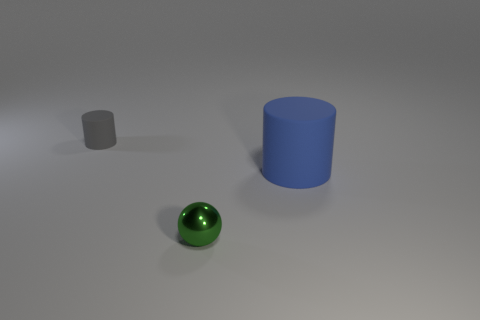Is the number of shiny cylinders greater than the number of large rubber cylinders?
Your answer should be very brief. No. Are there any other things that are the same color as the small matte thing?
Provide a succinct answer. No. The cylinder that is in front of the tiny thing behind the big blue matte cylinder is made of what material?
Your response must be concise. Rubber. There is a object on the left side of the small green object; is its shape the same as the small green object?
Offer a terse response. No. Is the number of rubber cylinders on the right side of the blue thing greater than the number of blue cylinders?
Your answer should be very brief. No. Is there any other thing that has the same material as the green object?
Provide a short and direct response. No. How many blocks are either small things or big blue things?
Offer a very short reply. 0. There is a rubber object to the left of the large blue cylinder on the right side of the tiny matte cylinder; what is its color?
Offer a very short reply. Gray. There is a metallic thing; is it the same color as the cylinder that is on the right side of the gray matte cylinder?
Ensure brevity in your answer.  No. There is a gray cylinder that is made of the same material as the big blue thing; what size is it?
Give a very brief answer. Small. 